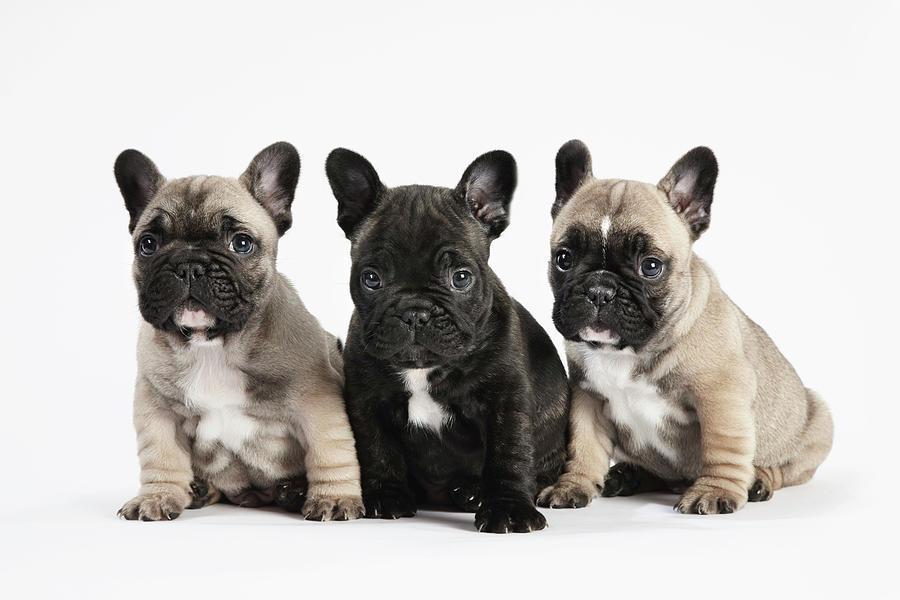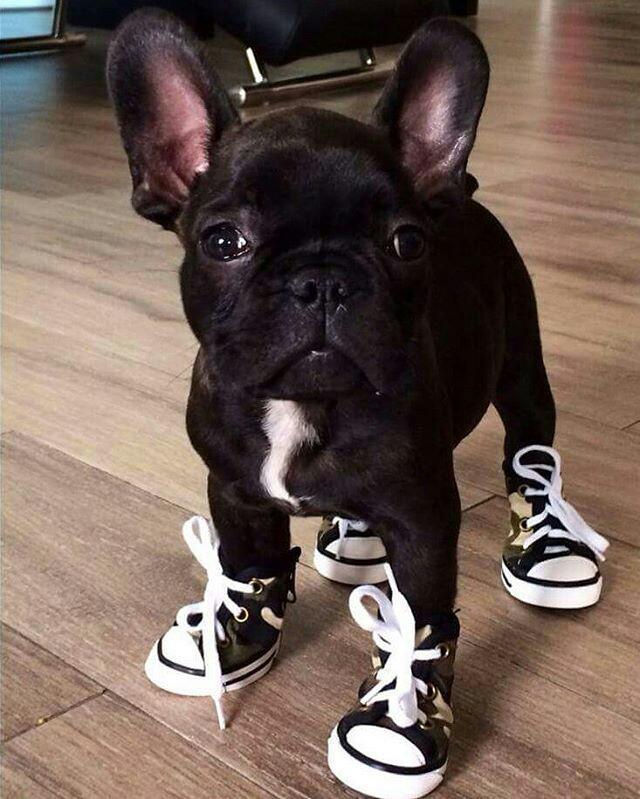The first image is the image on the left, the second image is the image on the right. Given the left and right images, does the statement "There is exactly one dog in one of the images." hold true? Answer yes or no. Yes. 